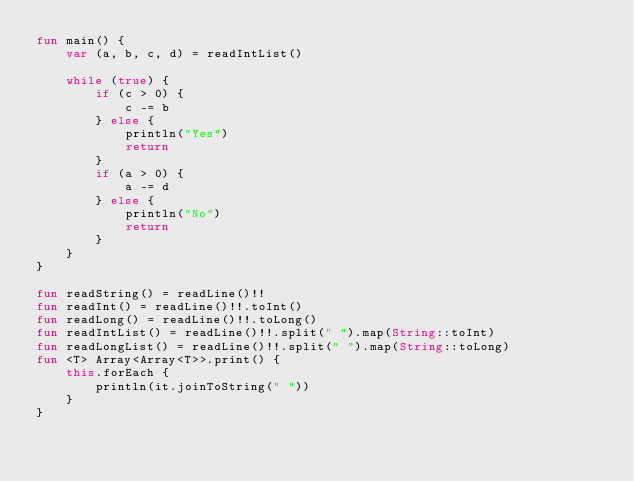Convert code to text. <code><loc_0><loc_0><loc_500><loc_500><_Kotlin_>fun main() {
    var (a, b, c, d) = readIntList()

    while (true) {
        if (c > 0) {
            c -= b
        } else {
            println("Yes")
            return
        }
        if (a > 0) {
            a -= d
        } else {
            println("No")
            return
        }
    }
}

fun readString() = readLine()!!
fun readInt() = readLine()!!.toInt()
fun readLong() = readLine()!!.toLong()
fun readIntList() = readLine()!!.split(" ").map(String::toInt)
fun readLongList() = readLine()!!.split(" ").map(String::toLong)
fun <T> Array<Array<T>>.print() {
    this.forEach {
        println(it.joinToString(" "))
    }
}</code> 